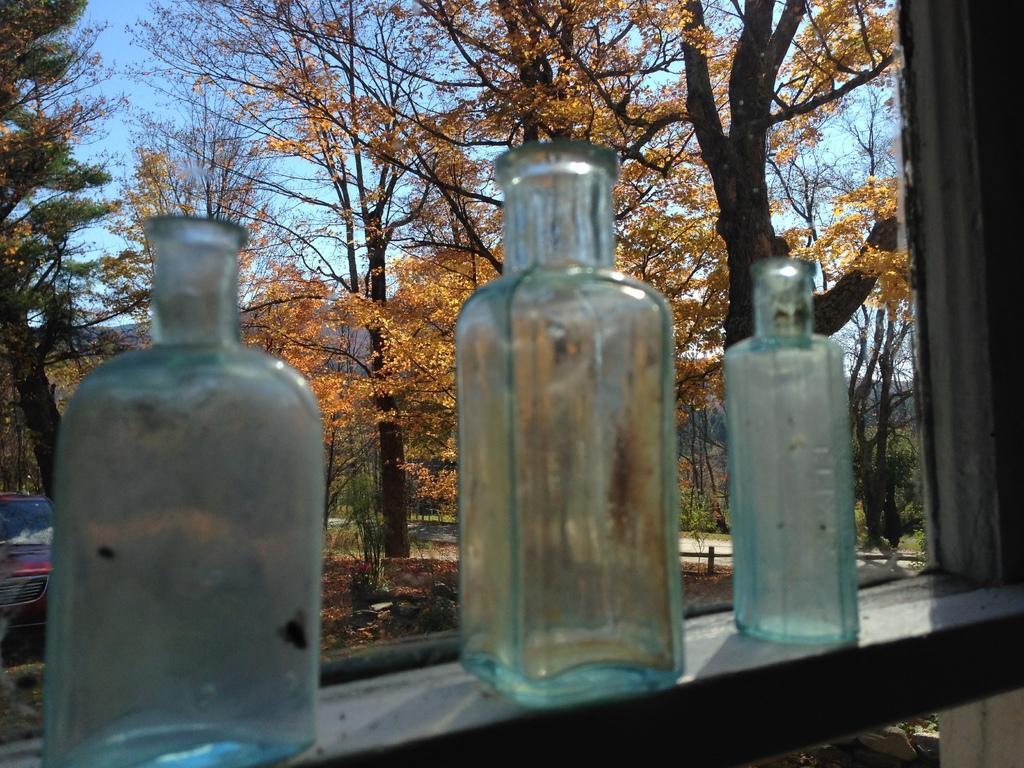How would you summarize this image in a sentence or two? As we can see in the image there are trees and three bottles. 